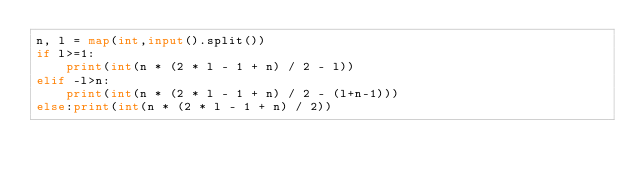<code> <loc_0><loc_0><loc_500><loc_500><_Python_>n, l = map(int,input().split())
if l>=1:
    print(int(n * (2 * l - 1 + n) / 2 - l))
elif -l>n:
    print(int(n * (2 * l - 1 + n) / 2 - (l+n-1)))
else:print(int(n * (2 * l - 1 + n) / 2))</code> 